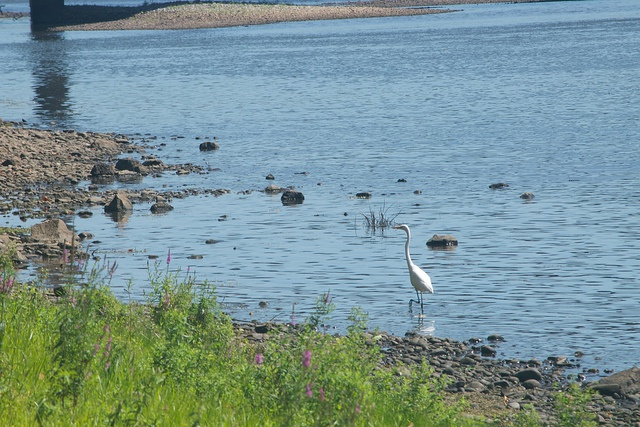Describe the objects in this image and their specific colors. I can see a bird in gray, white, and darkgray tones in this image. 